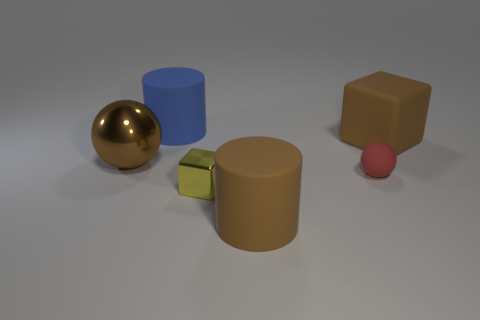Add 3 blue cylinders. How many objects exist? 9 Subtract all blocks. How many objects are left? 4 Add 4 large objects. How many large objects are left? 8 Add 1 big gray metallic blocks. How many big gray metallic blocks exist? 1 Subtract 0 gray blocks. How many objects are left? 6 Subtract all brown metallic balls. Subtract all tiny yellow cubes. How many objects are left? 4 